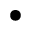Convert formula to latex. <formula><loc_0><loc_0><loc_500><loc_500>\bullet</formula> 